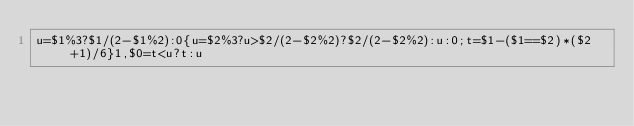Convert code to text. <code><loc_0><loc_0><loc_500><loc_500><_Awk_>u=$1%3?$1/(2-$1%2):0{u=$2%3?u>$2/(2-$2%2)?$2/(2-$2%2):u:0;t=$1-($1==$2)*($2+1)/6}1,$0=t<u?t:u</code> 